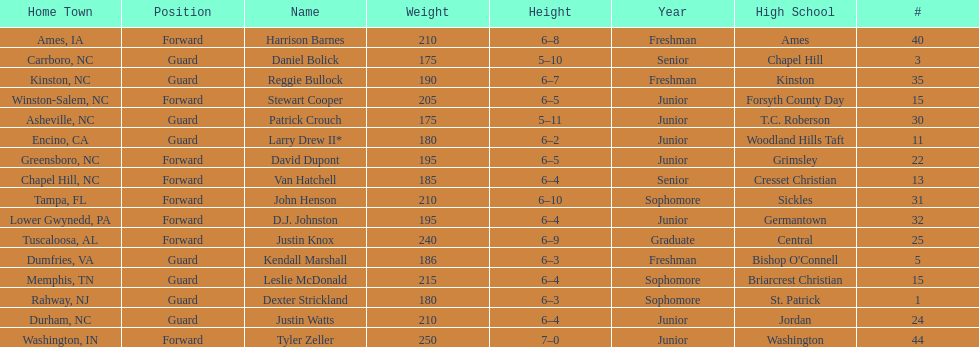Names of players who were exactly 6 feet, 4 inches tall, but did not weight over 200 pounds Van Hatchell, D.J. Johnston. 